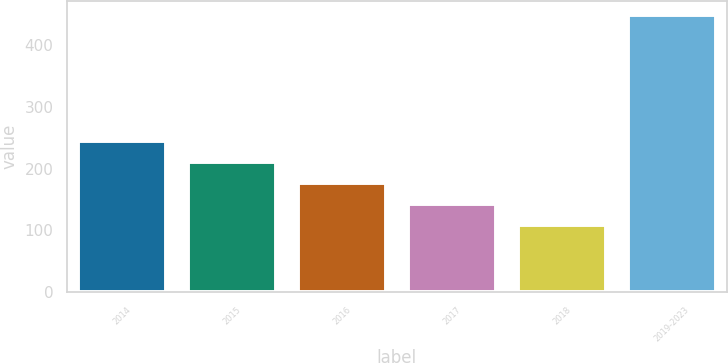Convert chart. <chart><loc_0><loc_0><loc_500><loc_500><bar_chart><fcel>2014<fcel>2015<fcel>2016<fcel>2017<fcel>2018<fcel>2019-2023<nl><fcel>244<fcel>210<fcel>176<fcel>142<fcel>108<fcel>448<nl></chart> 